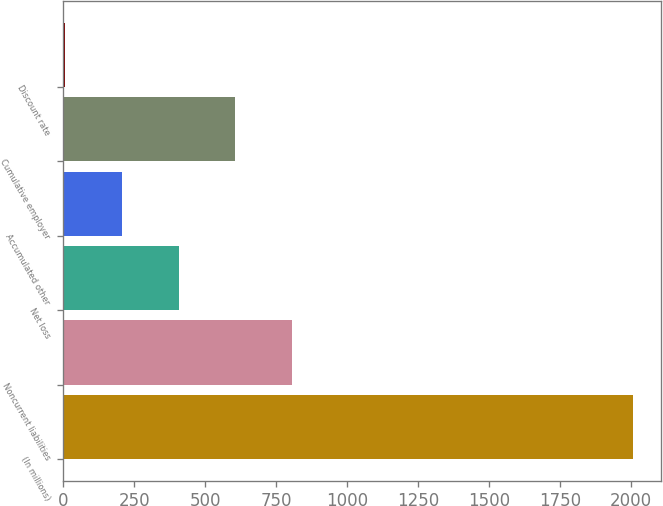Convert chart to OTSL. <chart><loc_0><loc_0><loc_500><loc_500><bar_chart><fcel>(In millions)<fcel>Noncurrent liabilities<fcel>Net loss<fcel>Accumulated other<fcel>Cumulative employer<fcel>Discount rate<nl><fcel>2007<fcel>806.4<fcel>406.2<fcel>206.1<fcel>606.3<fcel>6<nl></chart> 